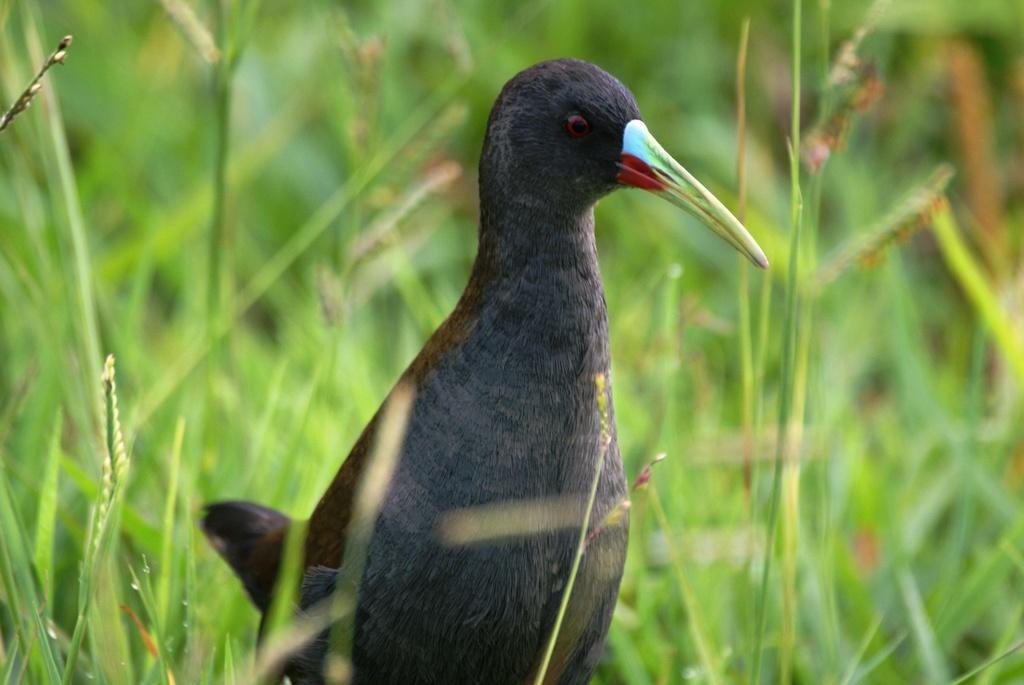Describe this image in one or two sentences. In the middle of this image there is black color bird looking at the right side. Around this, I can see the grass. 